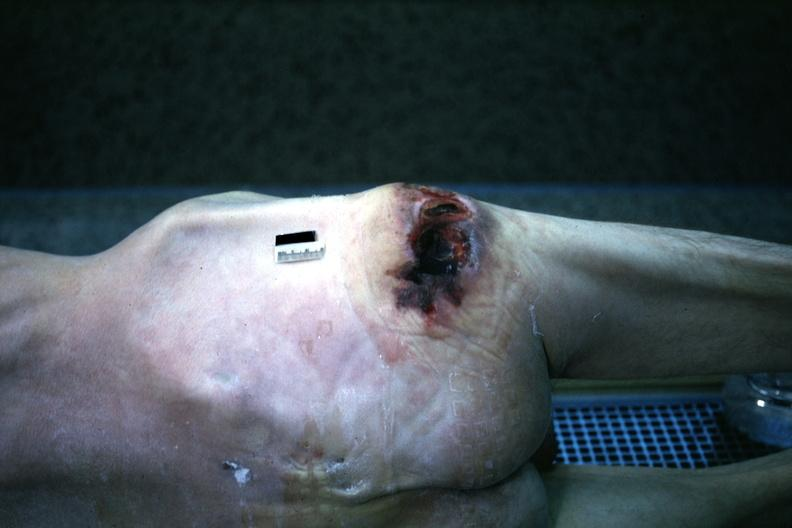what does this image show?
Answer the question using a single word or phrase. Large decubitus over right trochanter 